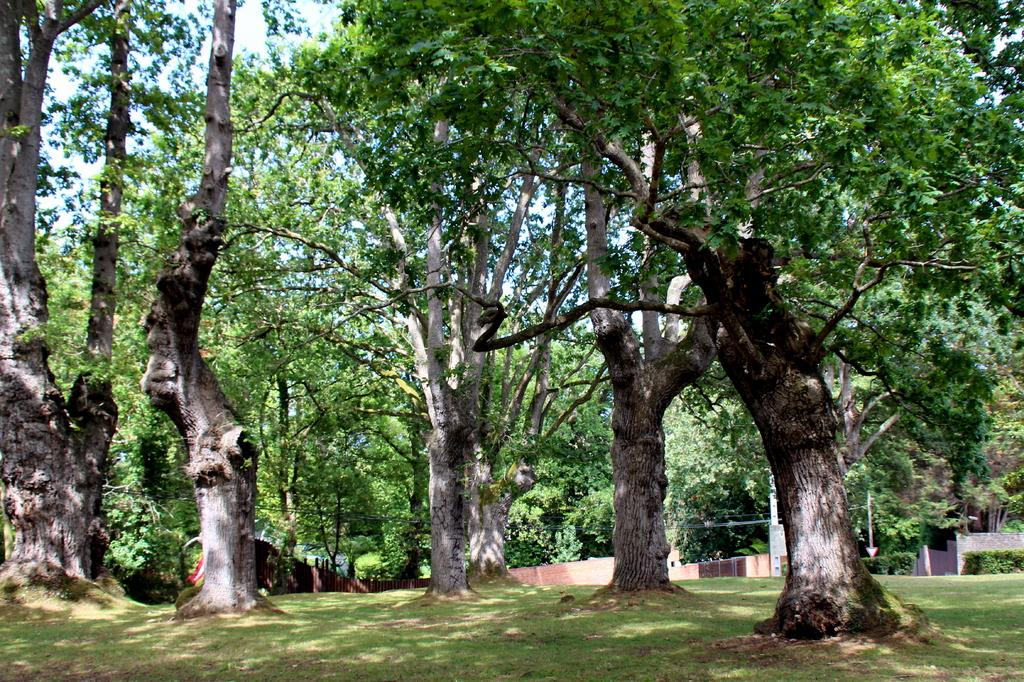What type of vegetation can be seen in the image? There are trees on the grassland in the image. What architectural feature is visible in the background of the image? There is a wall visible in the background of the image. What can be seen on the right side of the image? There are plants on the right side of the image. How does the fan help the trees in the image? There is no fan present in the image, so it cannot help the trees. What act are the plants on the right side of the image performing? The plants in the image are not performing any act; they are stationary vegetation. 